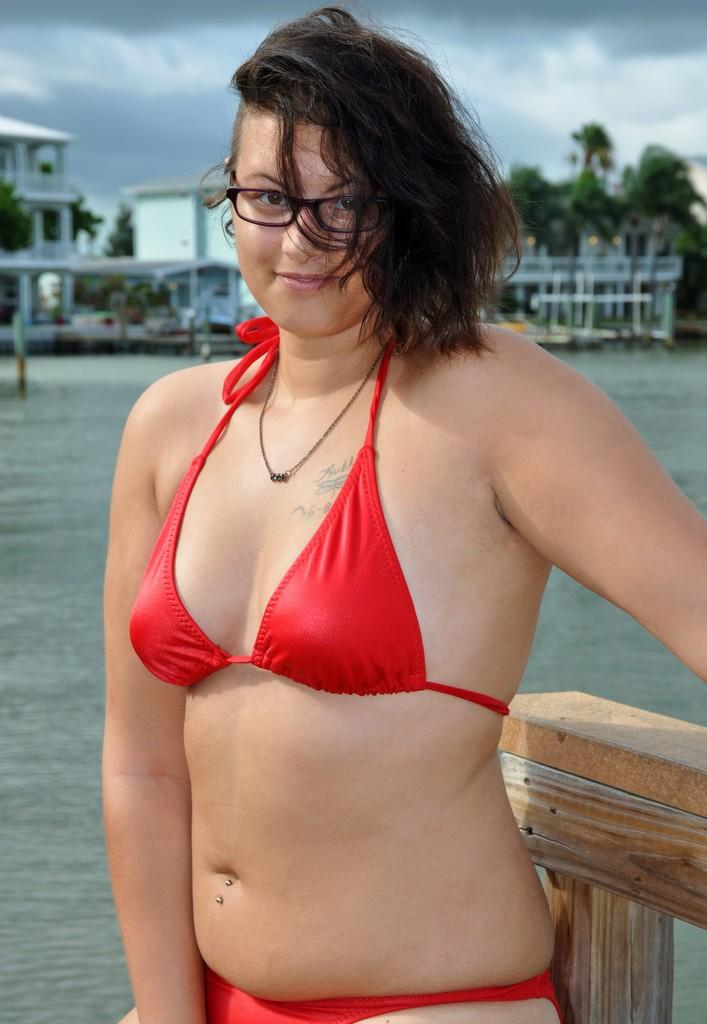Who is present in the image? There is a woman in the image. What is the woman doing in the image? The woman is standing behind a wooden fence. What is the woman wearing in the image? The woman is wearing a red bikini. What can be seen in the background of the image? There is a pond, buildings, trees, and the sky visible in the background of the image. What is the condition of the sky in the image? The sky is visible, and clouds are present in the image. What flavor of fairies can be seen flying around the woman in the image? There are no fairies present in the image, and therefore no flavors can be associated with them. 